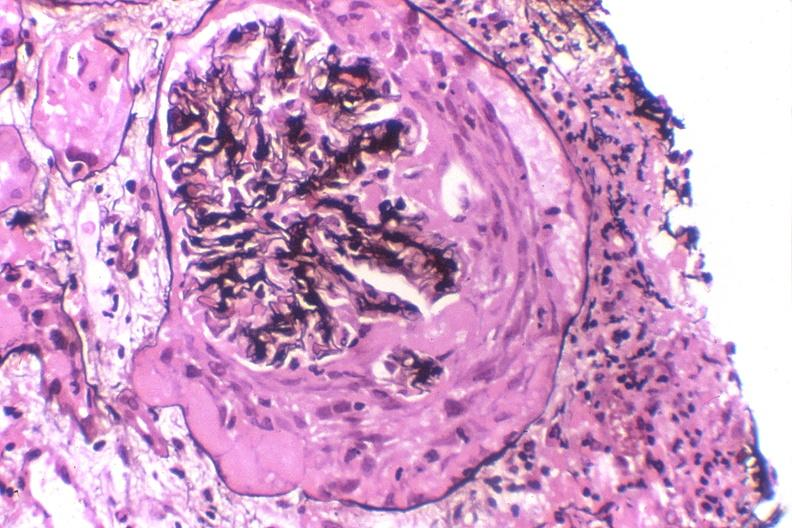s normal immature infant present?
Answer the question using a single word or phrase. No 